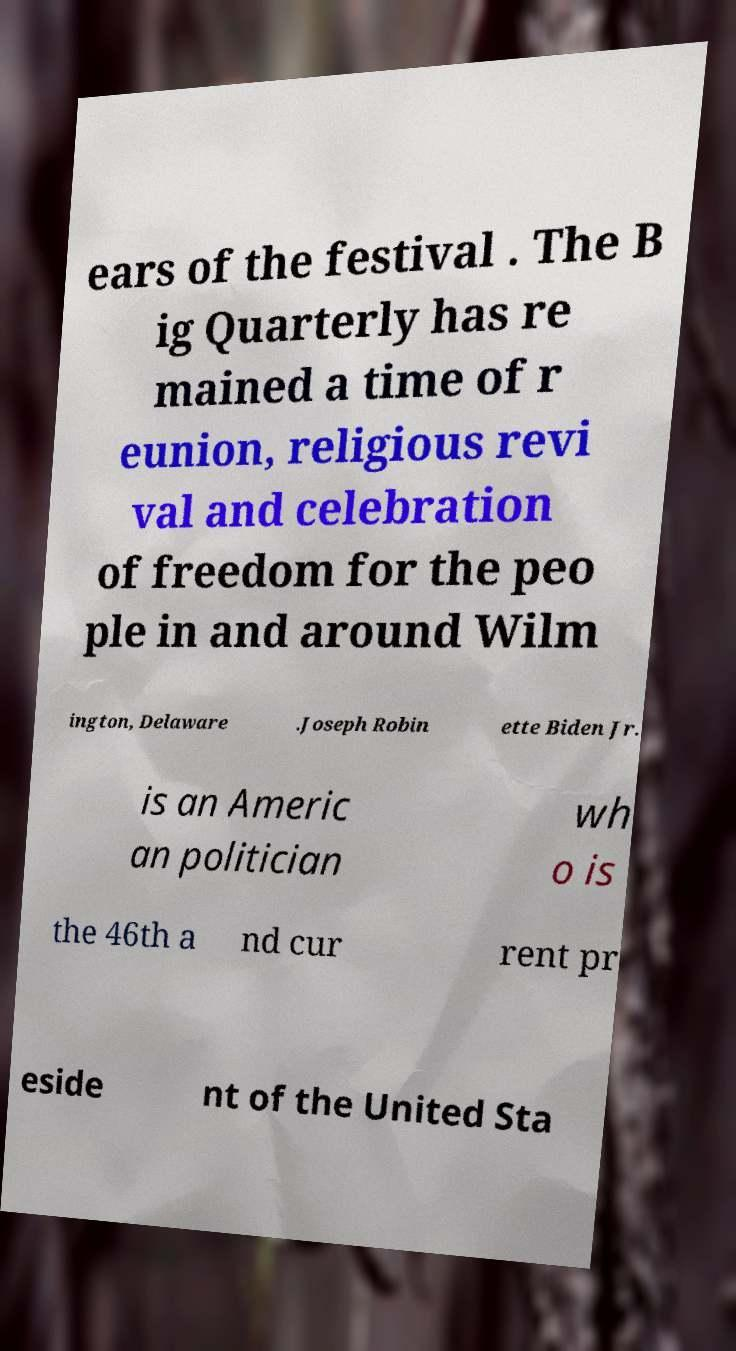Could you extract and type out the text from this image? ears of the festival . The B ig Quarterly has re mained a time of r eunion, religious revi val and celebration of freedom for the peo ple in and around Wilm ington, Delaware .Joseph Robin ette Biden Jr. is an Americ an politician wh o is the 46th a nd cur rent pr eside nt of the United Sta 